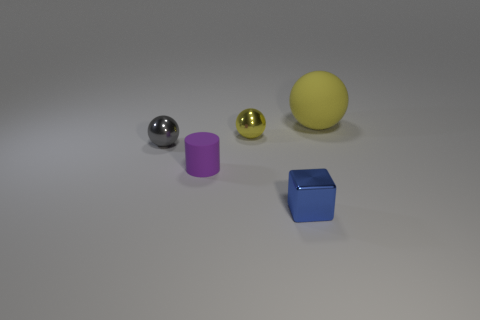Add 1 tiny red metallic objects. How many objects exist? 6 Subtract all cylinders. How many objects are left? 4 Add 3 tiny matte things. How many tiny matte things are left? 4 Add 3 tiny green rubber blocks. How many tiny green rubber blocks exist? 3 Subtract 0 yellow cubes. How many objects are left? 5 Subtract all small gray spheres. Subtract all small metallic objects. How many objects are left? 1 